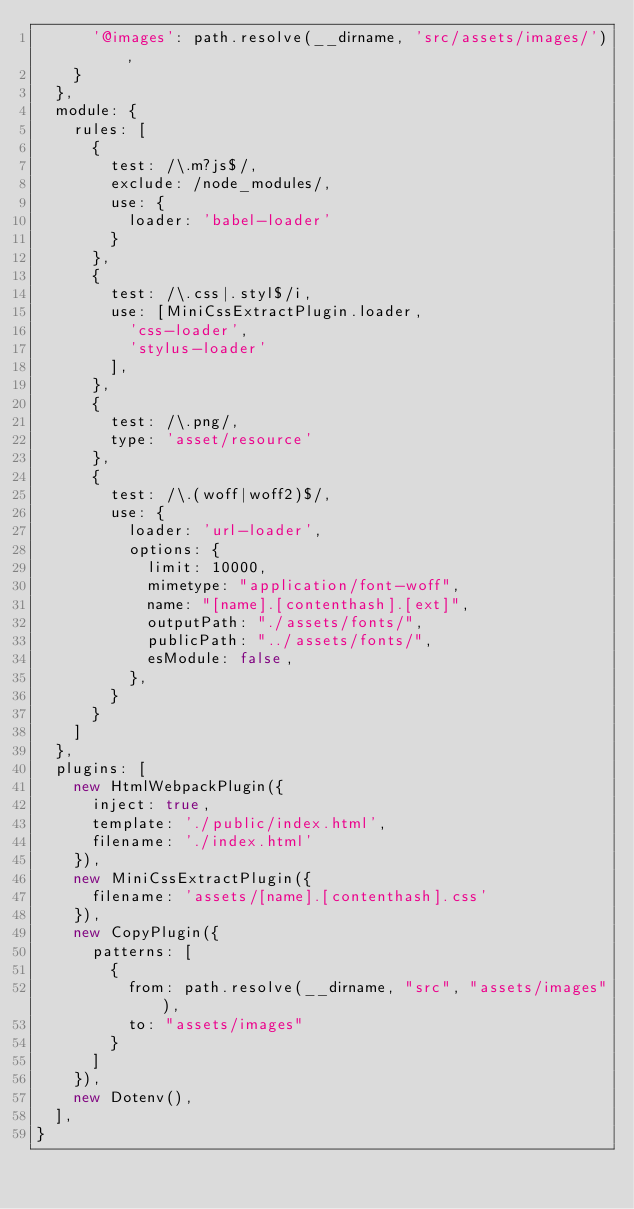<code> <loc_0><loc_0><loc_500><loc_500><_JavaScript_>      '@images': path.resolve(__dirname, 'src/assets/images/'),
    }
  },
  module: {
    rules: [
      {
        test: /\.m?js$/,
        exclude: /node_modules/,
        use: {
          loader: 'babel-loader'
        }
      },
      {
        test: /\.css|.styl$/i,
        use: [MiniCssExtractPlugin.loader,
          'css-loader',
          'stylus-loader'
        ],
      },
      {
        test: /\.png/,
        type: 'asset/resource'
      },
      {
        test: /\.(woff|woff2)$/,
        use: {
          loader: 'url-loader',
          options: {
            limit: 10000,
            mimetype: "application/font-woff",
            name: "[name].[contenthash].[ext]",
            outputPath: "./assets/fonts/",
            publicPath: "../assets/fonts/",
            esModule: false,
          },
        }
      }
    ]
  },
  plugins: [
    new HtmlWebpackPlugin({
      inject: true,
      template: './public/index.html',
      filename: './index.html'
    }),
    new MiniCssExtractPlugin({
      filename: 'assets/[name].[contenthash].css'
    }),
    new CopyPlugin({
      patterns: [
        {
          from: path.resolve(__dirname, "src", "assets/images"),
          to: "assets/images"
        }
      ]
    }),
    new Dotenv(),
  ],
} 
</code> 